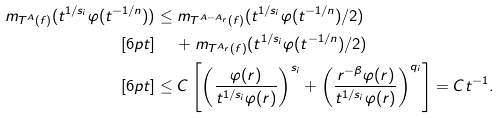Convert formula to latex. <formula><loc_0><loc_0><loc_500><loc_500>m _ { T ^ { A } ( f ) } ( t ^ { 1 / s _ { i } } \varphi ( t ^ { - 1 / n } ) ) & \leq m _ { T ^ { A - A _ { r } } ( f ) } ( t ^ { 1 / s _ { i } } \varphi ( t ^ { - 1 / n } ) / 2 ) \\ [ 6 p t ] & \quad \, + m _ { T ^ { A _ { r } } ( f ) } ( t ^ { 1 / s _ { i } } \varphi ( t ^ { - 1 / n } ) / 2 ) \\ [ 6 p t ] & \leq C \left [ \left ( \frac { \varphi ( r ) } { t ^ { 1 / s _ { i } } \varphi ( r ) } \right ) ^ { s _ { i } } + \left ( \frac { r ^ { - \beta } \varphi ( r ) } { t ^ { 1 / s _ { i } } \varphi ( r ) } \right ) ^ { q _ { i } } \right ] = C t ^ { - 1 } .</formula> 